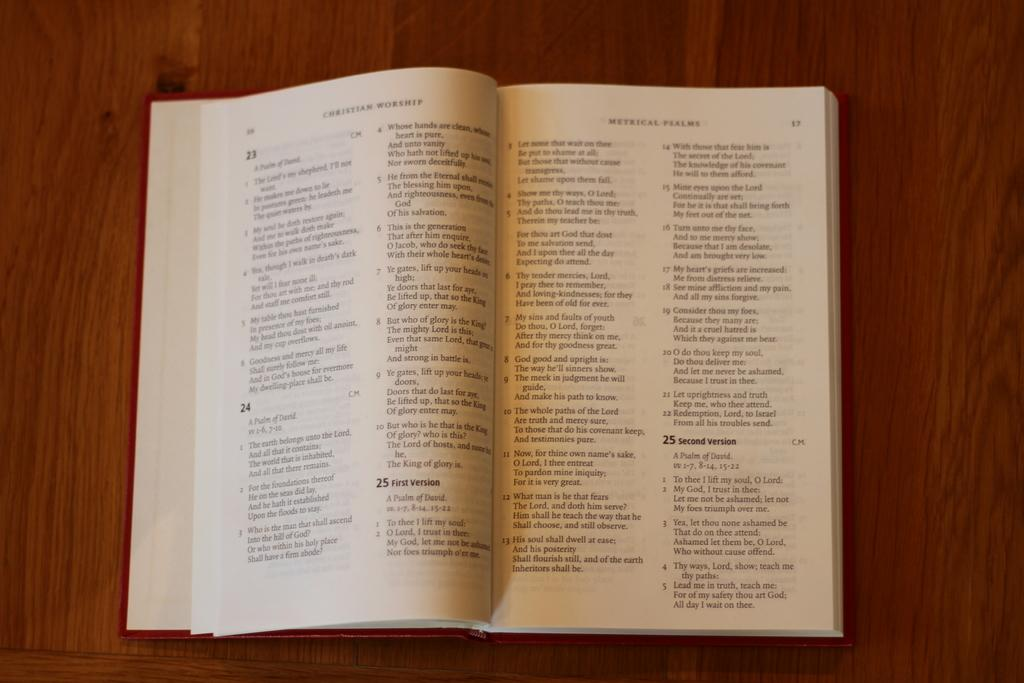<image>
Provide a brief description of the given image. Christian Worship book with different verses and psalms. 